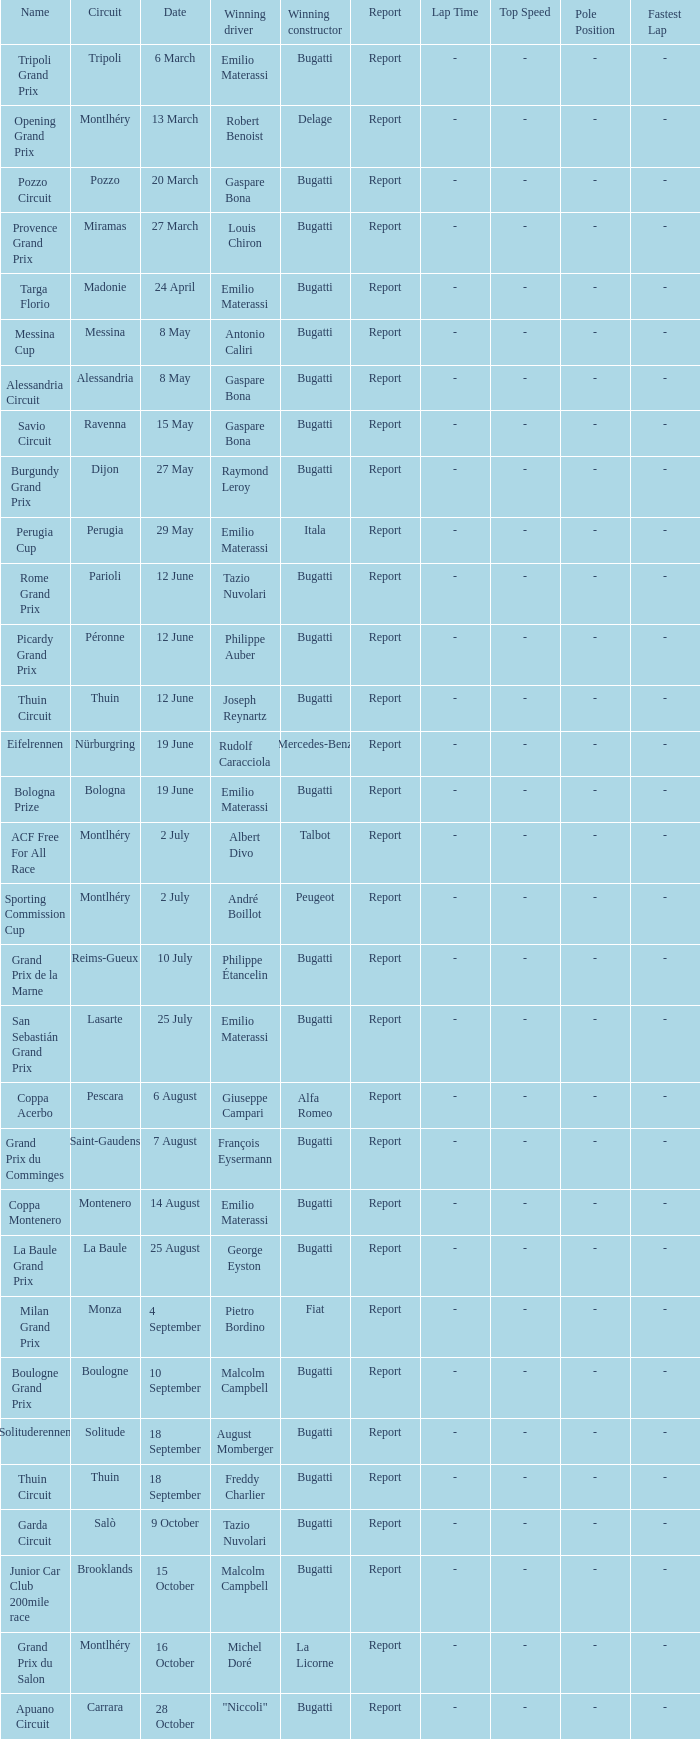On which circuit was françois eysermann victorious? Saint-Gaudens. 